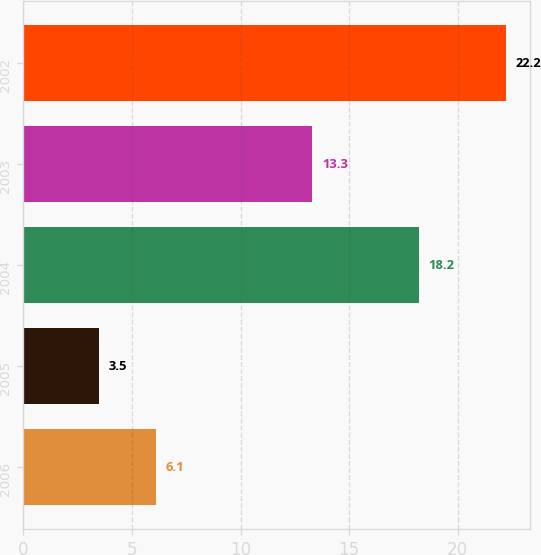<chart> <loc_0><loc_0><loc_500><loc_500><bar_chart><fcel>2006<fcel>2005<fcel>2004<fcel>2003<fcel>2002<nl><fcel>6.1<fcel>3.5<fcel>18.2<fcel>13.3<fcel>22.2<nl></chart> 